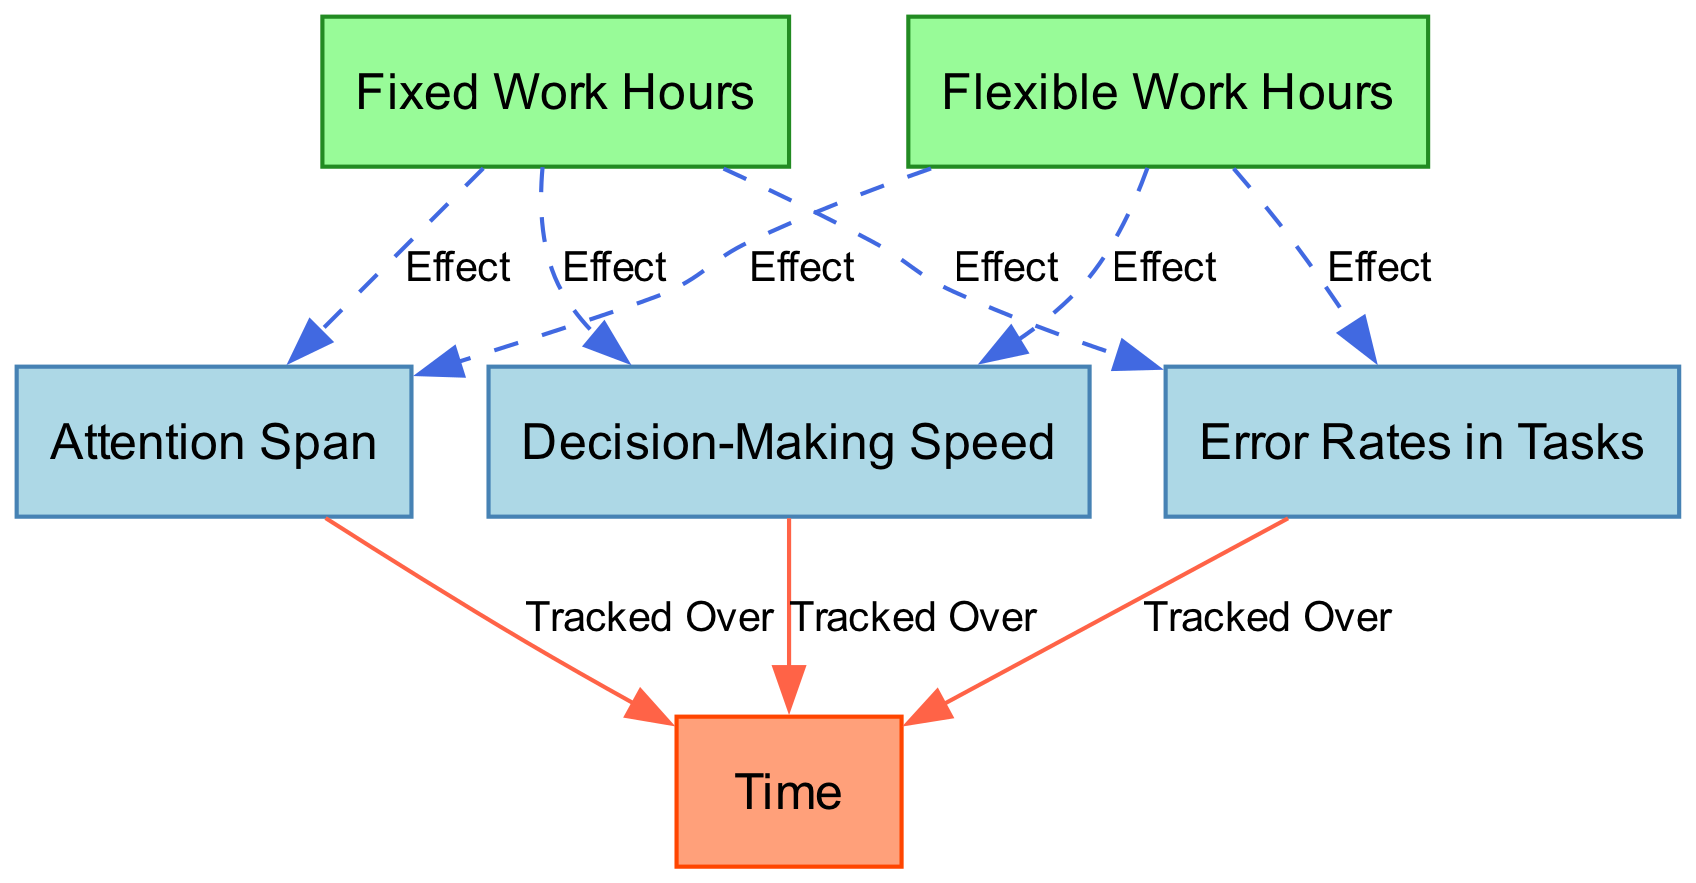What are the three cognitive performance metrics shown in the diagram? The diagram lists three cognitive performance metrics: Attention Span, Error Rates in Tasks, and Decision-Making Speed. These are specifically mentioned within their respective nodes.
Answer: Attention Span, Error Rates in Tasks, Decision-Making Speed How many work schedules are represented in the diagram? The diagram represents two work schedules, as indicated by the nodes labeled Fixed Work Hours and Flexible Work Hours.
Answer: 2 Which work schedule has a direct effect on Decision-Making Speed? The edge labeled "Effect" connects Fixed Work Hours to Decision-Making Speed, indicating that Fixed Work Hours directly affects this metric.
Answer: Fixed Work Hours What type of line connects the Flexible Work Hours to the Attention Span? The line connecting Flexible Work Hours to Attention Span is dashed, indicating that it represents an "Effect" relationship.
Answer: Dashed How does the attention span change over time according to the diagram? There is an edge labeled "Tracked Over" from Attention Span to Time, which implies that Attention Span is monitored as time progresses.
Answer: Monitored What is the relationship between Error Rates in Tasks and Fixed Work Hours? The diagram shows a direct edge labeled "Effect" from Fixed Work Hours to Error Rates in Tasks, establishing a cause-effect relationship between the two.
Answer: Effect Where are the cognitive metrics tracked in relation to time? Each of the cognitive metrics (Attention Span, Error Rates in Tasks, Decision-Making Speed) has an edge connecting to the Time node, indicating that all metrics are tracked over time.
Answer: All metrics Which performance metric is linked to both work schedules? Attention Span is the only metric with direct edges from both Fixed Work Hours and Flexible Work Hours, showing its connection to both work schedules.
Answer: Attention Span 